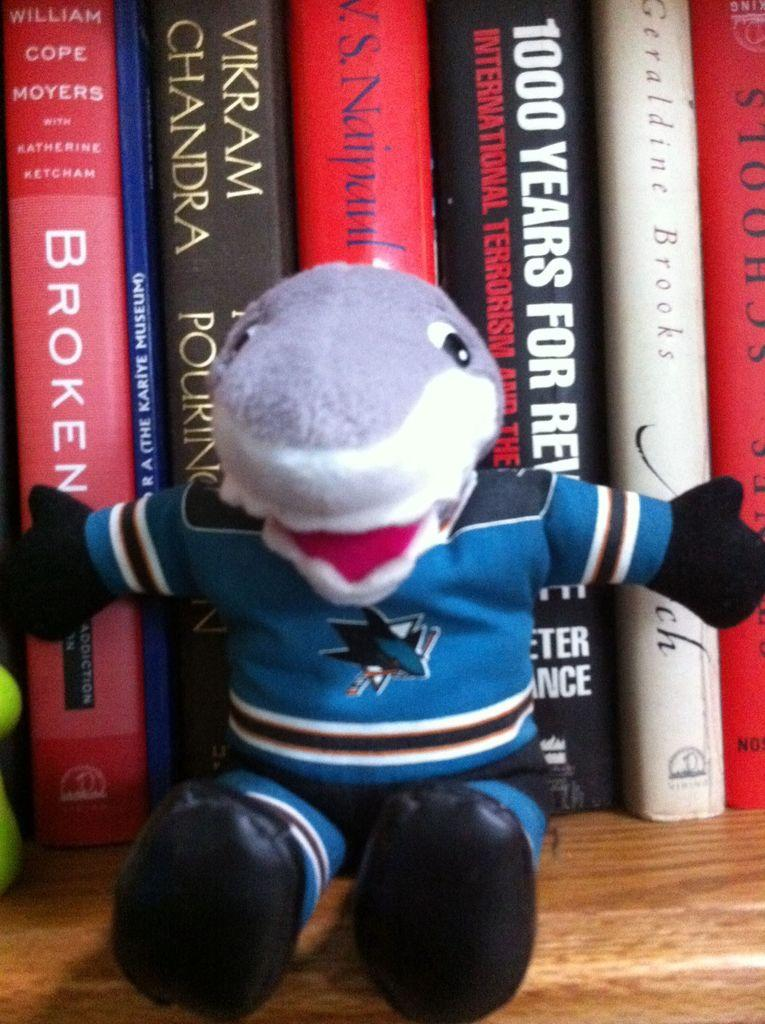Provide a one-sentence caption for the provided image. a shark mascot in front of books like Broken. 